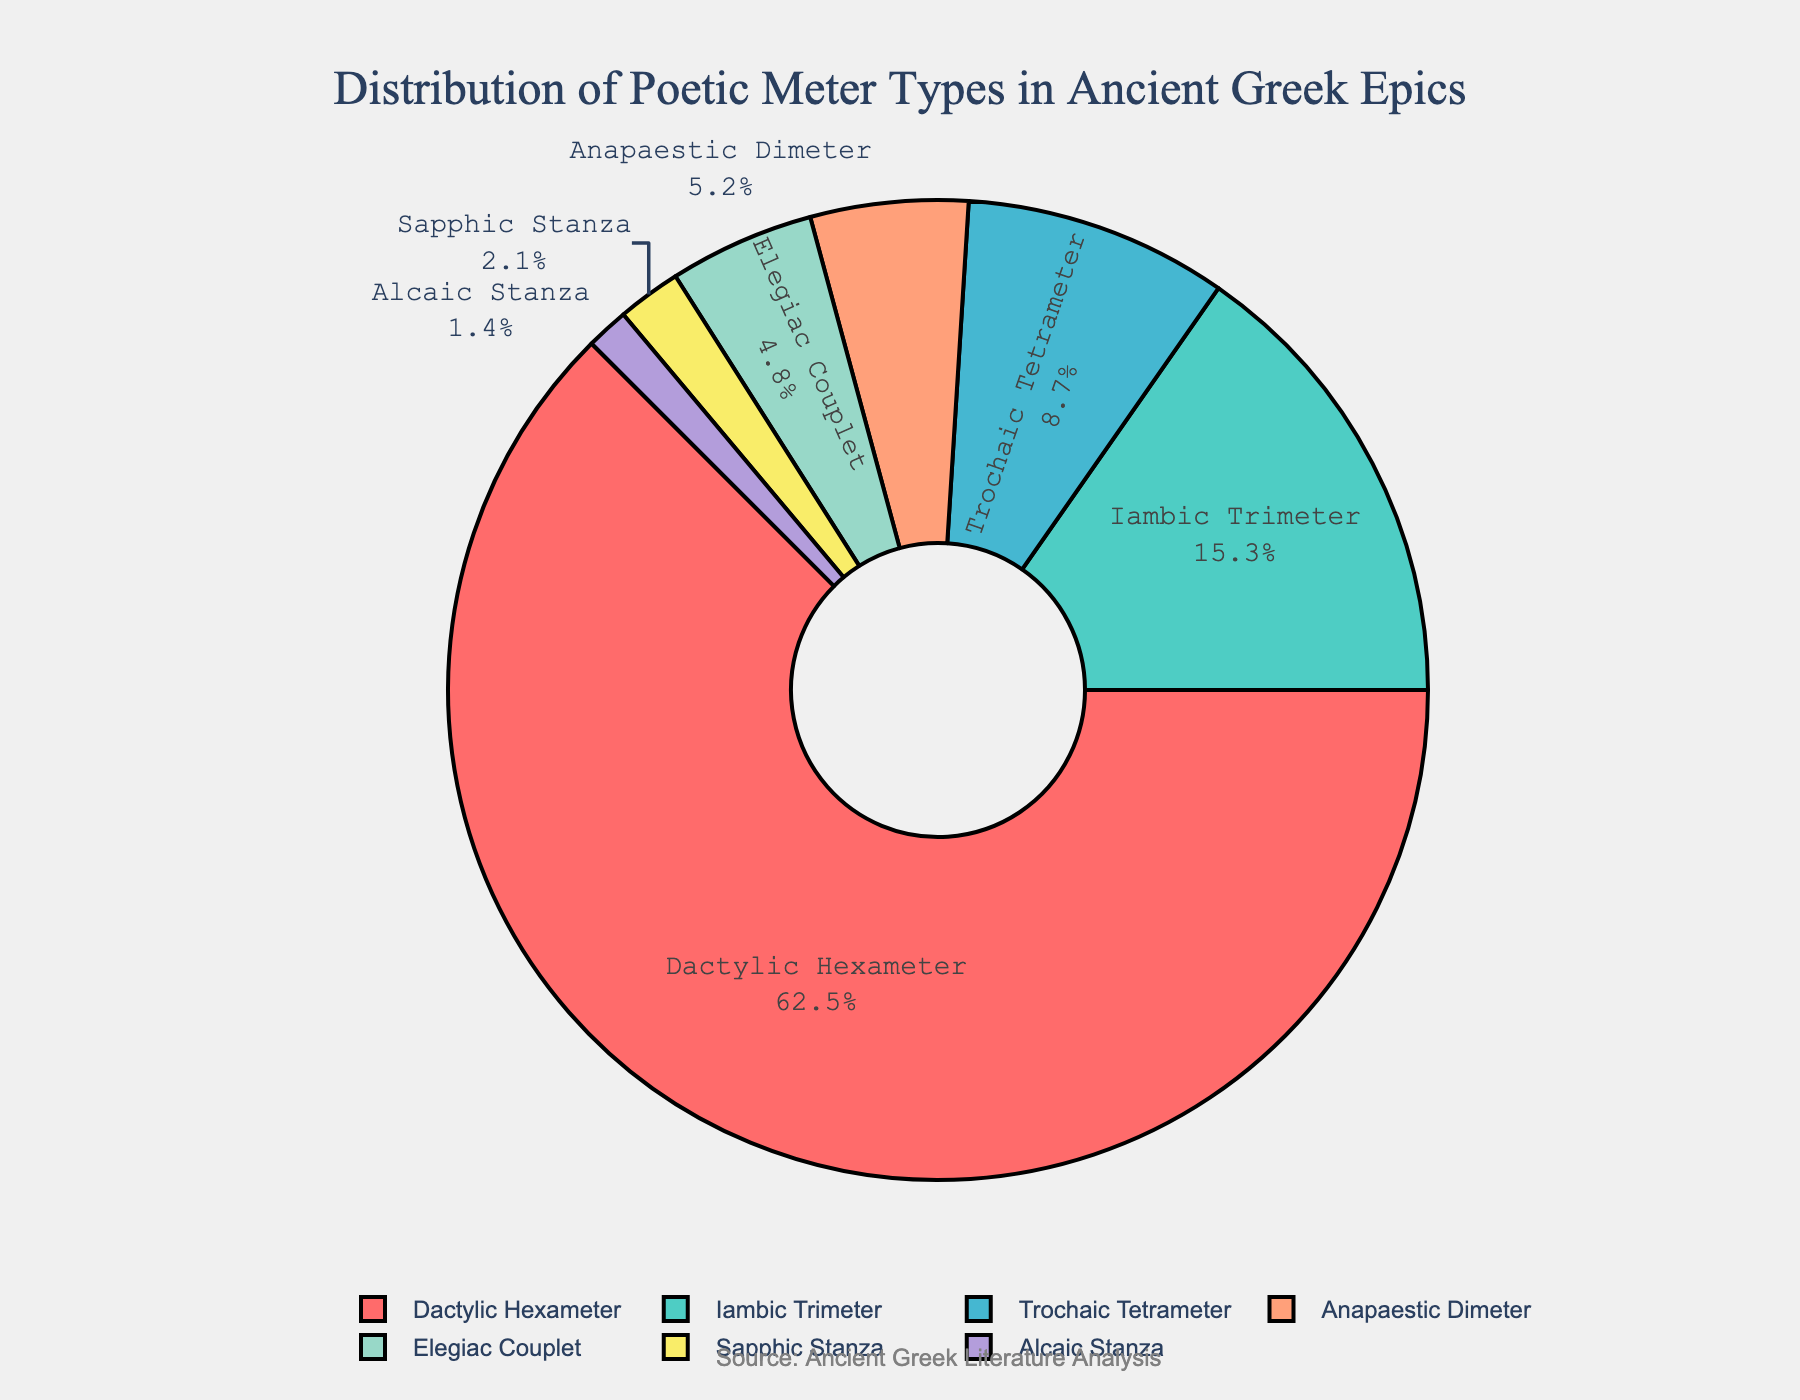What is the percentage of Anapaestic Dimeter in the dataset? Locate the section labeled "Anapaestic Dimeter" in the chart and read its associated percentage value.
Answer: 5.2% Which meter type has the largest percentage share? Identify the meter type with the largest section in the pie chart. The label usually contains the percentage as well, showing that "Dactylic Hexameter" occupies the largest part.
Answer: Dactylic Hexameter What is the combined percentage of Trochaic Tetrameter and Elegiac Couplet? Locate the sections of "Trochaic Tetrameter" and "Elegiac Couplet" and sum their percentages: 8.7% + 4.8% = 13.5%.
Answer: 13.5% Which meter types have a percentage less than 5%? Identify and list the sections in the chart with percentages below 5%. These include: "Elegiac Couplet," "Sapphic Stanza," and "Alcaic Stanza."
Answer: Elegiac Couplet, Sapphic Stanza, Alcaic Stanza How much greater is the percentage of Dactylic Hexameter compared to Iambic Trimeter? Subtract the percentage of Iambic Trimeter from Dactylic Hexameter: 62.5% - 15.3% = 47.2%.
Answer: 47.2% Which colors represent Dactylic Hexameter and Sapphic Stanza in the chart? Identify and describe the colors of the "Dactylic Hexameter" and "Sapphic Stanza" sections from the visual representation. Dactylic Hexameter is represented by red, while Sapphic Stanza is represented by yellow.
Answer: Red and Yellow What is the second most common poetic meter in ancient Greek epics? After identifying the meter type with the highest percentage (Dactylic Hexameter), find the next largest section which is labeled "Iambic Trimeter."
Answer: Iambic Trimeter What is the percentage difference between Trochaic Tetrameter and Sapphic Stanza? Subtract the percentage of Sapphic Stanza from Trochaic Tetrameter: 8.7% - 2.1% = 6.6%.
Answer: 6.6% Is there any meter type whose share is less than 2%? Identify and check the percentages shown in the chart. The smallest percentage (1.4% for Alcaic Stanza) is still noticeable and less than 2%.
Answer: Yes, Alcaic Stanza Arrange the meter types in descending order based on their percentage. List each meter type based on their percentage from highest to lowest: Dactylic Hexameter, Iambic Trimeter, Trochaic Tetrameter, Anapaestic Dimeter, Elegiac Couplet, Sapphic Stanza, Alcaic Stanza.
Answer: Dactylic Hexameter, Iambic Trimeter, Trochaic Tetrameter, Anapaestic Dimeter, Elegiac Couplet, Sapphic Stanza, Alcaic Stanza 